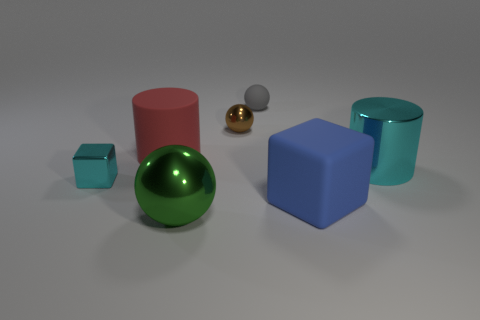There is a brown metallic object that is the same shape as the tiny rubber thing; what is its size?
Make the answer very short. Small. Do the metallic block and the rubber block have the same size?
Offer a very short reply. No. Is the number of metal things that are left of the small brown object greater than the number of big blue matte objects left of the large red cylinder?
Provide a succinct answer. Yes. Are there any red objects that have the same shape as the big cyan object?
Make the answer very short. Yes. There is a red rubber thing that is the same size as the cyan shiny cylinder; what is its shape?
Ensure brevity in your answer.  Cylinder. There is a small metallic object that is left of the big green thing; what is its shape?
Ensure brevity in your answer.  Cube. Is the number of big matte objects on the right side of the large cyan thing less than the number of metal things on the right side of the big green thing?
Give a very brief answer. Yes. Do the cyan block and the sphere in front of the big cyan metallic thing have the same size?
Ensure brevity in your answer.  No. How many other things are the same size as the red rubber thing?
Your answer should be very brief. 3. There is a block that is the same material as the gray object; what color is it?
Give a very brief answer. Blue. 